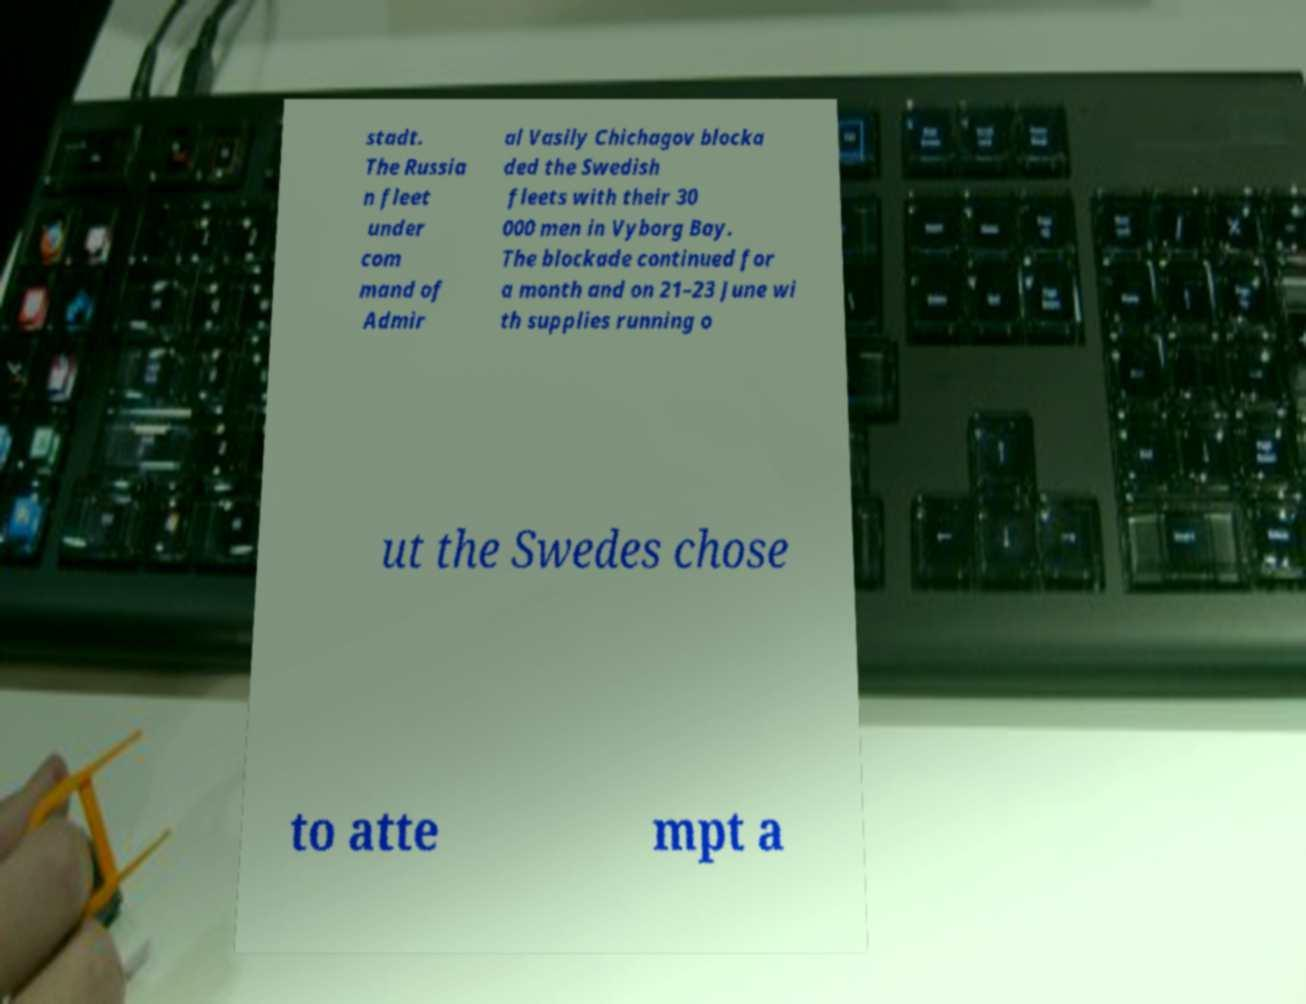For documentation purposes, I need the text within this image transcribed. Could you provide that? stadt. The Russia n fleet under com mand of Admir al Vasily Chichagov blocka ded the Swedish fleets with their 30 000 men in Vyborg Bay. The blockade continued for a month and on 21–23 June wi th supplies running o ut the Swedes chose to atte mpt a 